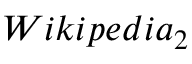<formula> <loc_0><loc_0><loc_500><loc_500>W i k i p e d i a _ { 2 }</formula> 